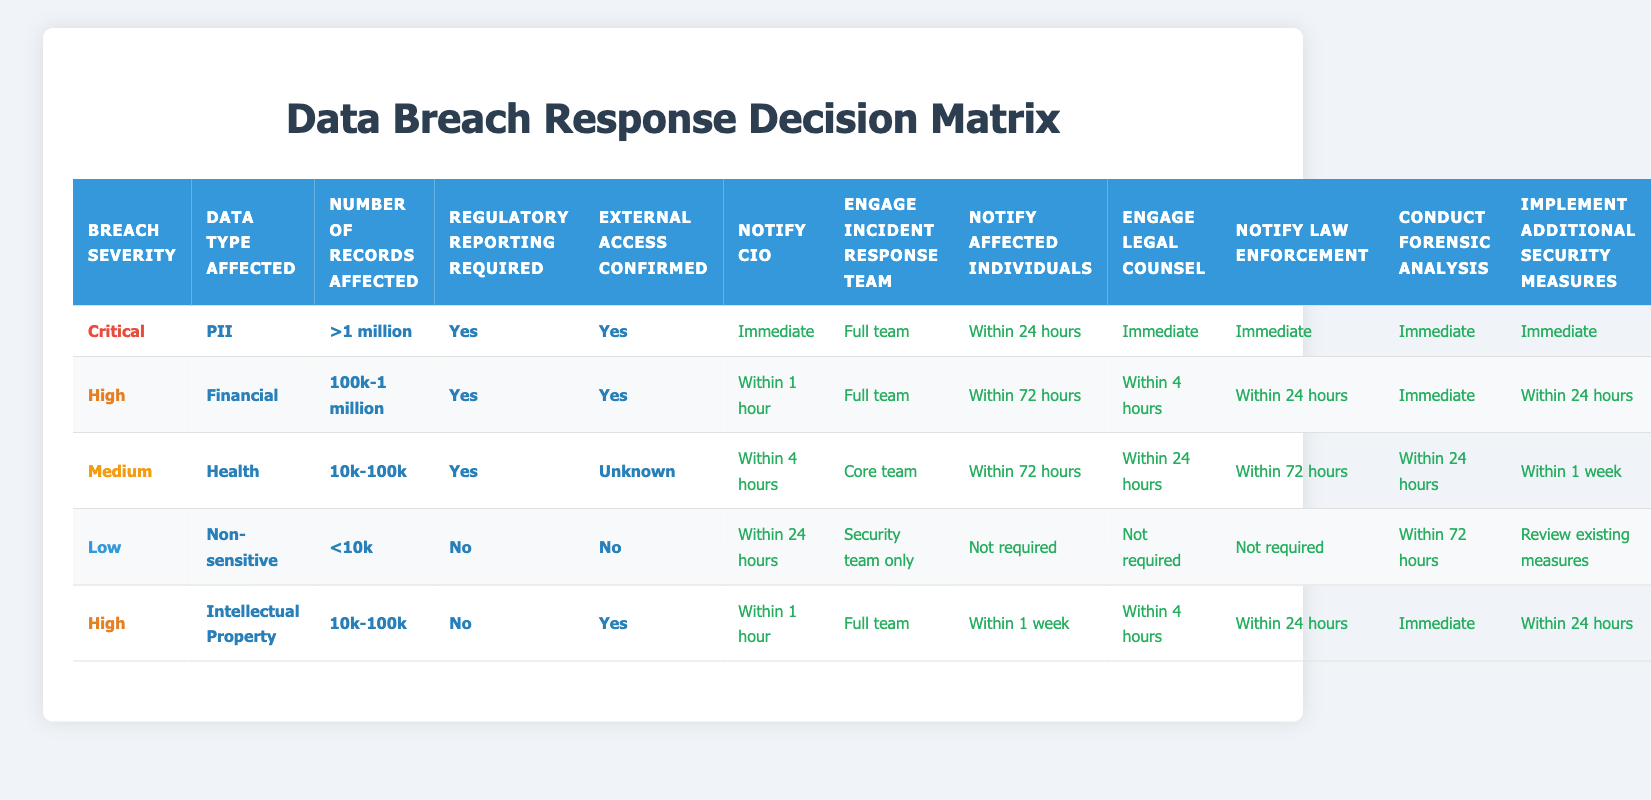What are the actions required when a data breach is categorized as 'Critical' with PII data and over 1 million records affected? Referring to the row in the table where the conditions are 'Critical', 'PII', and '>1 million', the actions specified are: Notify CIO - Immediate, Engage Incident Response Team - Full team, Notify Affected Individuals - Within 24 hours, Engage Legal Counsel - Immediate, Notify Law Enforcement - Immediate, Conduct Forensic Analysis - Immediate, Implement Additional Security Measures - Immediate.
Answer: Immediate, Full team, Within 24 hours, Immediate, Immediate, Immediate, Immediate Under which conditions is 'Not required' for notifying affected individuals? Examining the table, 'Not required' for notifying affected individuals only appears in the row with conditions 'Low', 'Non-sensitive', and '<10k' records. This indicates that if the breach severity is low, the data type is non-sensitive, and fewer than 10k records are affected, notifying affected individuals is not required.
Answer: Low, Non-sensitive, <10k What is the time frame for engaging the incident response team when the breach is classified as 'High' with Financial data? The relevant row shows that for a 'High' severity breach with Financial data and between 100k to 1 million records affected, the engagement of the incident response team is categorized as 'Full team'. This is a direct action, so the time frame is immediate.
Answer: Full team How many actions require immediate response in total for breaches classified as 'Critical'? From the 'Critical' breach row, there are a total of 7 actions specified, 5 of which require an immediate response: Notify CIO, Engage Incident Response Team, Engage Legal Counsel, Notify Law Enforcement, Conduct Forensic Analysis, and Implement Additional Security Measures. Hence, there are 5 actions in total requiring an immediate response.
Answer: 5 Is there any case where 'Engage Legal Counsel' is marked as 'Not required'? By looking through the table, the only row that indicates 'Not required' for 'Engage Legal Counsel' is found under the conditions of 'Low' severity, 'Non-sensitive' data, and '<10k' records. Therefore, this is the sole case where engaging legal counsel is not required.
Answer: Yes What is the time frame for conducting a forensic analysis when the breach is categorized as 'Medium' with Health data? The row for 'Medium' severity with Health data and between 10k to 100k records indicates that the forensic analysis should be conducted 'Within 24 hours'. This matches the requirement set out in the corresponding actions for this breach type.
Answer: Within 24 hours How does the number of records affected correlate to the immediacy of notifying the CIO? By checking the rows, we can see that for critical and high breaches (both situations with more than 100k records affected), the notifications to the CIO are required either immediately or within 1 hour. Conversely, for a 'Low' breach (with <10k records), notifying the CIO is limited to 'Within 24 hours', indicating that as the severity increases and the number of records affected rises, the urgency in notifying the CIO also increases.
Answer: Increases with severity In what scenario should law enforcement be notified within 72 hours? The conditions specifying that law enforcement should be notified 'Within 72 hours' occur in the 'Medium' severity row with Health data and 'Yes' for regulatory reporting requirement. This shows the conditions under which law enforcement notification is extended to 72 hours.
Answer: Medium, Health, Yes 